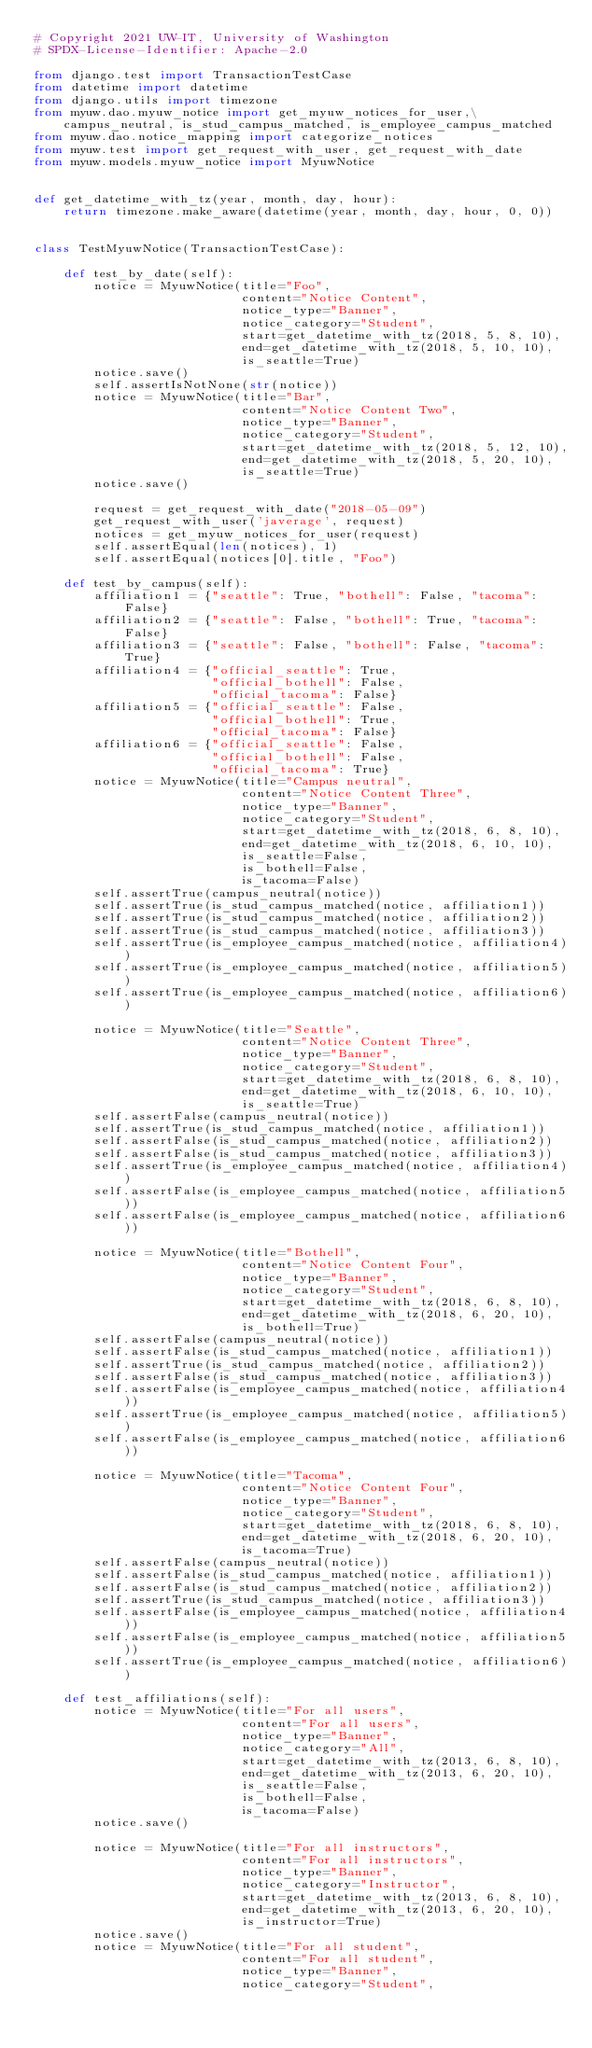Convert code to text. <code><loc_0><loc_0><loc_500><loc_500><_Python_># Copyright 2021 UW-IT, University of Washington
# SPDX-License-Identifier: Apache-2.0

from django.test import TransactionTestCase
from datetime import datetime
from django.utils import timezone
from myuw.dao.myuw_notice import get_myuw_notices_for_user,\
    campus_neutral, is_stud_campus_matched, is_employee_campus_matched
from myuw.dao.notice_mapping import categorize_notices
from myuw.test import get_request_with_user, get_request_with_date
from myuw.models.myuw_notice import MyuwNotice


def get_datetime_with_tz(year, month, day, hour):
    return timezone.make_aware(datetime(year, month, day, hour, 0, 0))


class TestMyuwNotice(TransactionTestCase):

    def test_by_date(self):
        notice = MyuwNotice(title="Foo",
                            content="Notice Content",
                            notice_type="Banner",
                            notice_category="Student",
                            start=get_datetime_with_tz(2018, 5, 8, 10),
                            end=get_datetime_with_tz(2018, 5, 10, 10),
                            is_seattle=True)
        notice.save()
        self.assertIsNotNone(str(notice))
        notice = MyuwNotice(title="Bar",
                            content="Notice Content Two",
                            notice_type="Banner",
                            notice_category="Student",
                            start=get_datetime_with_tz(2018, 5, 12, 10),
                            end=get_datetime_with_tz(2018, 5, 20, 10),
                            is_seattle=True)
        notice.save()

        request = get_request_with_date("2018-05-09")
        get_request_with_user('javerage', request)
        notices = get_myuw_notices_for_user(request)
        self.assertEqual(len(notices), 1)
        self.assertEqual(notices[0].title, "Foo")

    def test_by_campus(self):
        affiliation1 = {"seattle": True, "bothell": False, "tacoma": False}
        affiliation2 = {"seattle": False, "bothell": True, "tacoma": False}
        affiliation3 = {"seattle": False, "bothell": False, "tacoma": True}
        affiliation4 = {"official_seattle": True,
                        "official_bothell": False,
                        "official_tacoma": False}
        affiliation5 = {"official_seattle": False,
                        "official_bothell": True,
                        "official_tacoma": False}
        affiliation6 = {"official_seattle": False,
                        "official_bothell": False,
                        "official_tacoma": True}
        notice = MyuwNotice(title="Campus neutral",
                            content="Notice Content Three",
                            notice_type="Banner",
                            notice_category="Student",
                            start=get_datetime_with_tz(2018, 6, 8, 10),
                            end=get_datetime_with_tz(2018, 6, 10, 10),
                            is_seattle=False,
                            is_bothell=False,
                            is_tacoma=False)
        self.assertTrue(campus_neutral(notice))
        self.assertTrue(is_stud_campus_matched(notice, affiliation1))
        self.assertTrue(is_stud_campus_matched(notice, affiliation2))
        self.assertTrue(is_stud_campus_matched(notice, affiliation3))
        self.assertTrue(is_employee_campus_matched(notice, affiliation4))
        self.assertTrue(is_employee_campus_matched(notice, affiliation5))
        self.assertTrue(is_employee_campus_matched(notice, affiliation6))

        notice = MyuwNotice(title="Seattle",
                            content="Notice Content Three",
                            notice_type="Banner",
                            notice_category="Student",
                            start=get_datetime_with_tz(2018, 6, 8, 10),
                            end=get_datetime_with_tz(2018, 6, 10, 10),
                            is_seattle=True)
        self.assertFalse(campus_neutral(notice))
        self.assertTrue(is_stud_campus_matched(notice, affiliation1))
        self.assertFalse(is_stud_campus_matched(notice, affiliation2))
        self.assertFalse(is_stud_campus_matched(notice, affiliation3))
        self.assertTrue(is_employee_campus_matched(notice, affiliation4))
        self.assertFalse(is_employee_campus_matched(notice, affiliation5))
        self.assertFalse(is_employee_campus_matched(notice, affiliation6))

        notice = MyuwNotice(title="Bothell",
                            content="Notice Content Four",
                            notice_type="Banner",
                            notice_category="Student",
                            start=get_datetime_with_tz(2018, 6, 8, 10),
                            end=get_datetime_with_tz(2018, 6, 20, 10),
                            is_bothell=True)
        self.assertFalse(campus_neutral(notice))
        self.assertFalse(is_stud_campus_matched(notice, affiliation1))
        self.assertTrue(is_stud_campus_matched(notice, affiliation2))
        self.assertFalse(is_stud_campus_matched(notice, affiliation3))
        self.assertFalse(is_employee_campus_matched(notice, affiliation4))
        self.assertTrue(is_employee_campus_matched(notice, affiliation5))
        self.assertFalse(is_employee_campus_matched(notice, affiliation6))

        notice = MyuwNotice(title="Tacoma",
                            content="Notice Content Four",
                            notice_type="Banner",
                            notice_category="Student",
                            start=get_datetime_with_tz(2018, 6, 8, 10),
                            end=get_datetime_with_tz(2018, 6, 20, 10),
                            is_tacoma=True)
        self.assertFalse(campus_neutral(notice))
        self.assertFalse(is_stud_campus_matched(notice, affiliation1))
        self.assertFalse(is_stud_campus_matched(notice, affiliation2))
        self.assertTrue(is_stud_campus_matched(notice, affiliation3))
        self.assertFalse(is_employee_campus_matched(notice, affiliation4))
        self.assertFalse(is_employee_campus_matched(notice, affiliation5))
        self.assertTrue(is_employee_campus_matched(notice, affiliation6))

    def test_affiliations(self):
        notice = MyuwNotice(title="For all users",
                            content="For all users",
                            notice_type="Banner",
                            notice_category="All",
                            start=get_datetime_with_tz(2013, 6, 8, 10),
                            end=get_datetime_with_tz(2013, 6, 20, 10),
                            is_seattle=False,
                            is_bothell=False,
                            is_tacoma=False)
        notice.save()

        notice = MyuwNotice(title="For all instructors",
                            content="For all instructors",
                            notice_type="Banner",
                            notice_category="Instructor",
                            start=get_datetime_with_tz(2013, 6, 8, 10),
                            end=get_datetime_with_tz(2013, 6, 20, 10),
                            is_instructor=True)
        notice.save()
        notice = MyuwNotice(title="For all student",
                            content="For all student",
                            notice_type="Banner",
                            notice_category="Student",</code> 